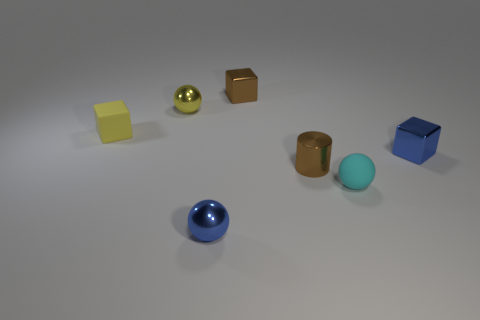What number of tiny shiny blocks have the same color as the tiny metal cylinder?
Your answer should be compact. 1. What color is the tiny metallic object that is both on the right side of the brown block and behind the small brown metal cylinder?
Provide a short and direct response. Blue. There is a small rubber object to the left of the brown shiny cylinder; what is its shape?
Offer a terse response. Cube. What size is the brown shiny block that is behind the tiny yellow object that is in front of the metallic sphere that is behind the small rubber sphere?
Provide a short and direct response. Small. What number of small cyan spheres are in front of the tiny rubber object behind the tiny metal cylinder?
Make the answer very short. 1. What is the size of the cube that is right of the yellow rubber block and behind the blue cube?
Provide a succinct answer. Small. What number of matte things are cyan objects or blue objects?
Offer a terse response. 1. What is the blue sphere made of?
Offer a terse response. Metal. There is a tiny blue object that is behind the tiny blue ball that is in front of the tiny brown shiny thing that is to the left of the brown metal cylinder; what is its material?
Your answer should be compact. Metal. There is a yellow object that is the same size as the yellow sphere; what shape is it?
Keep it short and to the point. Cube. 